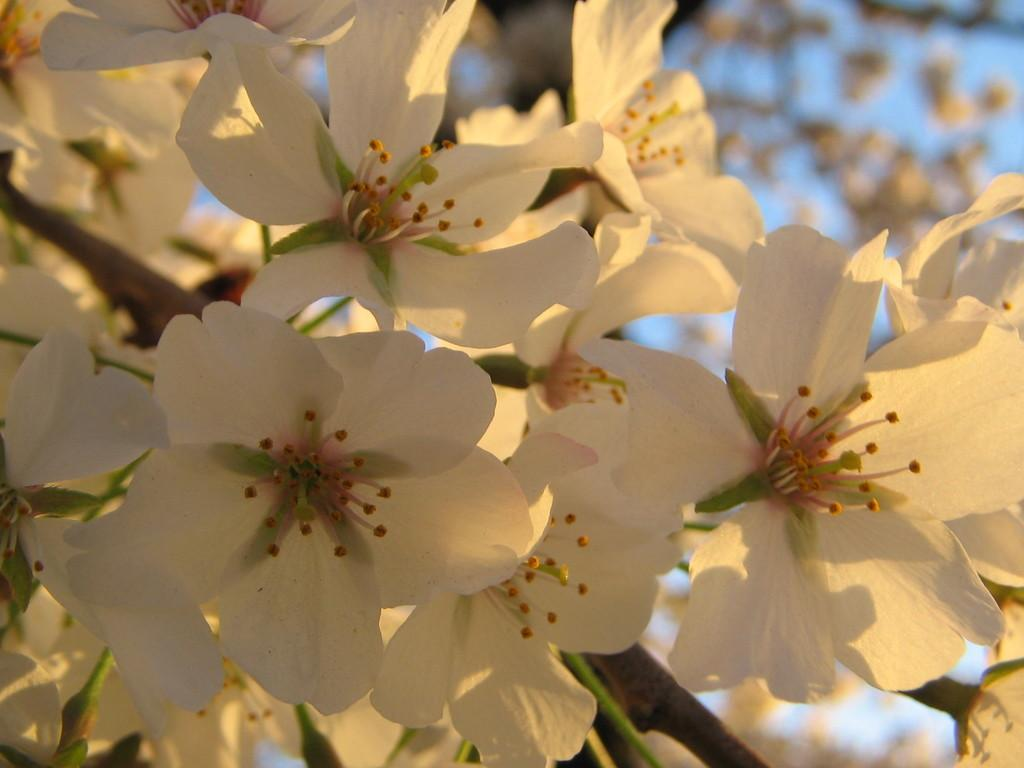What is located in the foreground of the image? There are flowers in the foreground of the image. What can be seen in the background of the image? There is sky visible in the background of the image. Are there any flowers in the background of the image? Yes, there are flowers in the background of the image. What type of noise can be heard coming from the chickens in the image? There are no chickens present in the image, so it's not possible to determine what, if any, noise might be heard. 